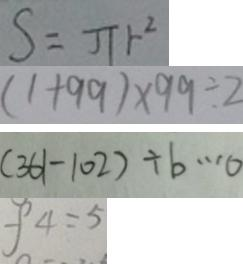Convert formula to latex. <formula><loc_0><loc_0><loc_500><loc_500>s = \pi r ^ { 2 } 
 ( 1 + 9 9 ) \times 9 9 \div 2 
 ( 3 6 1 - 1 0 2 ) \div b \cdots 0 
 f 4 = 5</formula> 